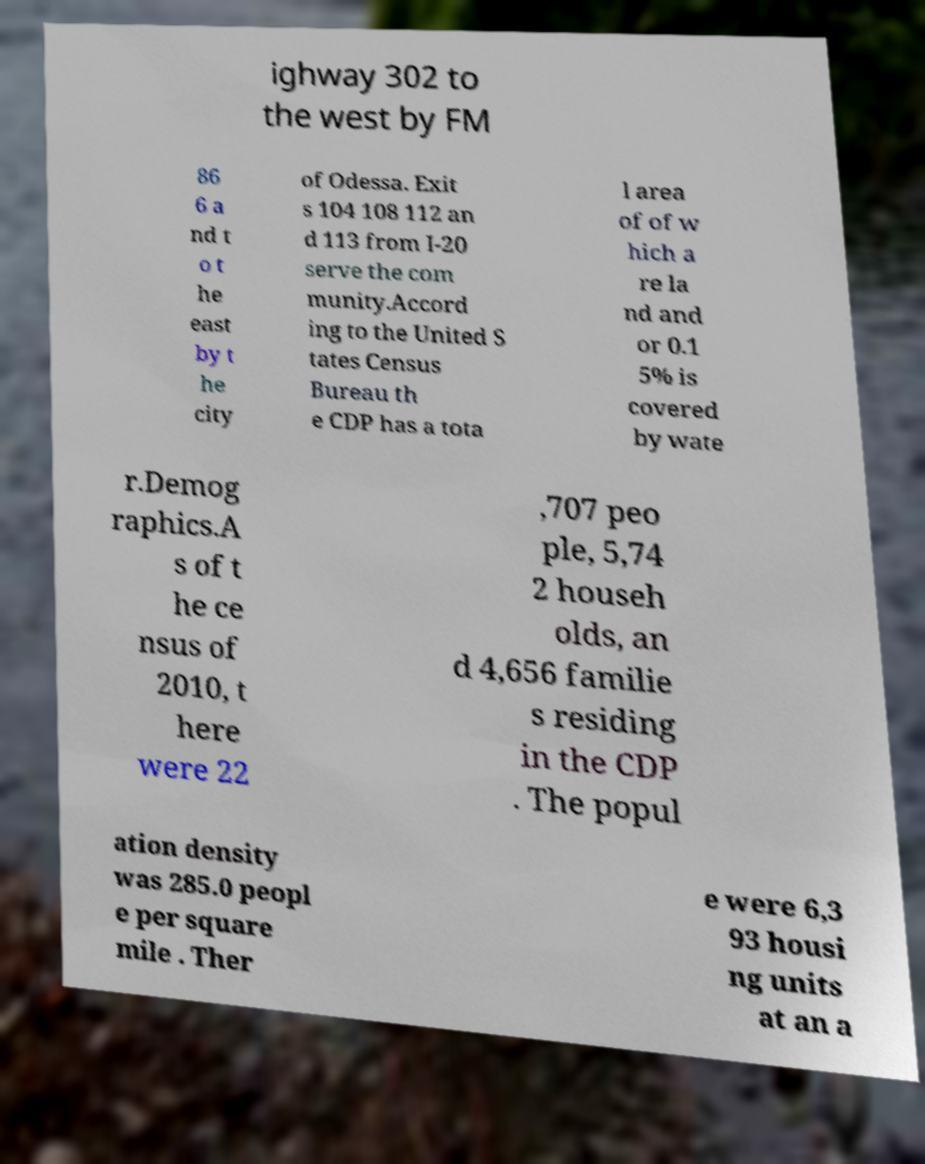Can you read and provide the text displayed in the image?This photo seems to have some interesting text. Can you extract and type it out for me? ighway 302 to the west by FM 86 6 a nd t o t he east by t he city of Odessa. Exit s 104 108 112 an d 113 from I-20 serve the com munity.Accord ing to the United S tates Census Bureau th e CDP has a tota l area of of w hich a re la nd and or 0.1 5% is covered by wate r.Demog raphics.A s of t he ce nsus of 2010, t here were 22 ,707 peo ple, 5,74 2 househ olds, an d 4,656 familie s residing in the CDP . The popul ation density was 285.0 peopl e per square mile . Ther e were 6,3 93 housi ng units at an a 